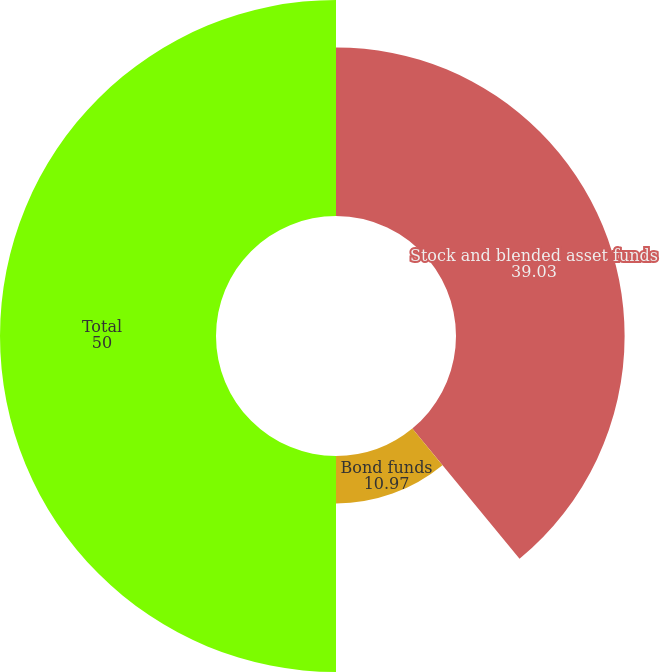<chart> <loc_0><loc_0><loc_500><loc_500><pie_chart><fcel>Stock and blended asset funds<fcel>Bond funds<fcel>Total<nl><fcel>39.03%<fcel>10.97%<fcel>50.0%<nl></chart> 